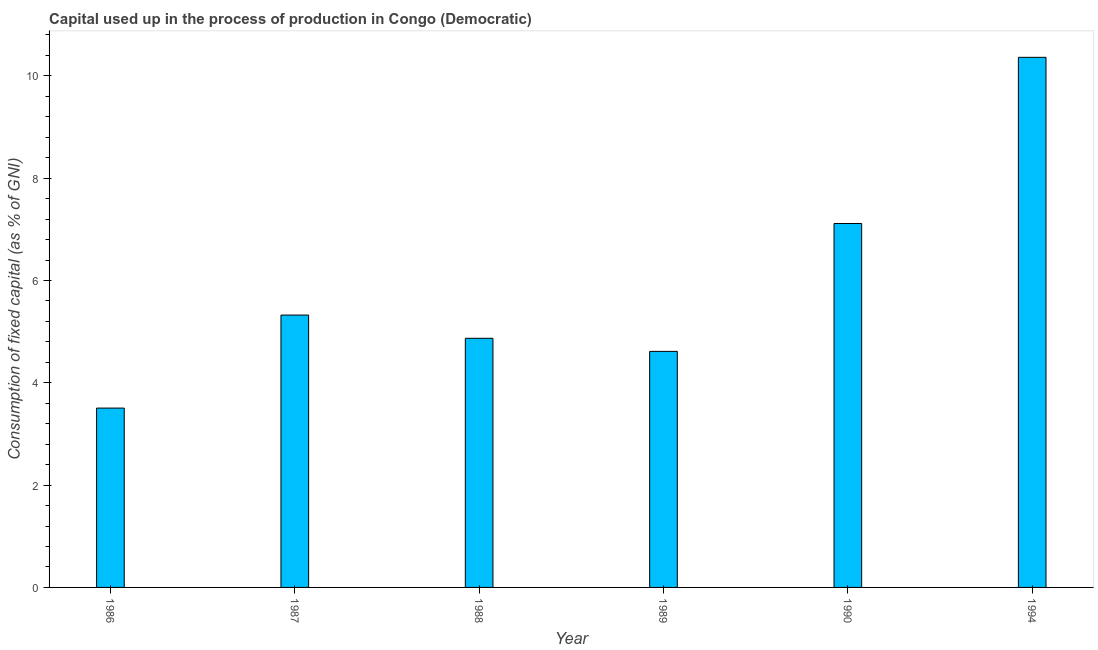What is the title of the graph?
Provide a succinct answer. Capital used up in the process of production in Congo (Democratic). What is the label or title of the X-axis?
Your answer should be compact. Year. What is the label or title of the Y-axis?
Provide a succinct answer. Consumption of fixed capital (as % of GNI). What is the consumption of fixed capital in 1987?
Ensure brevity in your answer.  5.32. Across all years, what is the maximum consumption of fixed capital?
Give a very brief answer. 10.36. Across all years, what is the minimum consumption of fixed capital?
Offer a terse response. 3.51. What is the sum of the consumption of fixed capital?
Provide a short and direct response. 35.79. What is the difference between the consumption of fixed capital in 1987 and 1988?
Offer a very short reply. 0.45. What is the average consumption of fixed capital per year?
Provide a short and direct response. 5.97. What is the median consumption of fixed capital?
Offer a very short reply. 5.1. In how many years, is the consumption of fixed capital greater than 8.4 %?
Provide a short and direct response. 1. Do a majority of the years between 1986 and 1987 (inclusive) have consumption of fixed capital greater than 2 %?
Your answer should be compact. Yes. What is the ratio of the consumption of fixed capital in 1988 to that in 1990?
Offer a very short reply. 0.69. Is the difference between the consumption of fixed capital in 1987 and 1989 greater than the difference between any two years?
Ensure brevity in your answer.  No. What is the difference between the highest and the second highest consumption of fixed capital?
Your response must be concise. 3.25. Is the sum of the consumption of fixed capital in 1987 and 1988 greater than the maximum consumption of fixed capital across all years?
Give a very brief answer. No. What is the difference between the highest and the lowest consumption of fixed capital?
Give a very brief answer. 6.86. In how many years, is the consumption of fixed capital greater than the average consumption of fixed capital taken over all years?
Give a very brief answer. 2. How many years are there in the graph?
Give a very brief answer. 6. What is the difference between two consecutive major ticks on the Y-axis?
Offer a very short reply. 2. What is the Consumption of fixed capital (as % of GNI) in 1986?
Make the answer very short. 3.51. What is the Consumption of fixed capital (as % of GNI) of 1987?
Offer a very short reply. 5.32. What is the Consumption of fixed capital (as % of GNI) in 1988?
Offer a terse response. 4.87. What is the Consumption of fixed capital (as % of GNI) in 1989?
Ensure brevity in your answer.  4.61. What is the Consumption of fixed capital (as % of GNI) of 1990?
Offer a terse response. 7.11. What is the Consumption of fixed capital (as % of GNI) in 1994?
Your answer should be compact. 10.36. What is the difference between the Consumption of fixed capital (as % of GNI) in 1986 and 1987?
Your answer should be compact. -1.82. What is the difference between the Consumption of fixed capital (as % of GNI) in 1986 and 1988?
Make the answer very short. -1.36. What is the difference between the Consumption of fixed capital (as % of GNI) in 1986 and 1989?
Provide a short and direct response. -1.11. What is the difference between the Consumption of fixed capital (as % of GNI) in 1986 and 1990?
Your answer should be very brief. -3.61. What is the difference between the Consumption of fixed capital (as % of GNI) in 1986 and 1994?
Your response must be concise. -6.86. What is the difference between the Consumption of fixed capital (as % of GNI) in 1987 and 1988?
Offer a terse response. 0.45. What is the difference between the Consumption of fixed capital (as % of GNI) in 1987 and 1989?
Provide a succinct answer. 0.71. What is the difference between the Consumption of fixed capital (as % of GNI) in 1987 and 1990?
Provide a short and direct response. -1.79. What is the difference between the Consumption of fixed capital (as % of GNI) in 1987 and 1994?
Ensure brevity in your answer.  -5.04. What is the difference between the Consumption of fixed capital (as % of GNI) in 1988 and 1989?
Keep it short and to the point. 0.26. What is the difference between the Consumption of fixed capital (as % of GNI) in 1988 and 1990?
Your answer should be compact. -2.24. What is the difference between the Consumption of fixed capital (as % of GNI) in 1988 and 1994?
Your response must be concise. -5.49. What is the difference between the Consumption of fixed capital (as % of GNI) in 1989 and 1990?
Ensure brevity in your answer.  -2.5. What is the difference between the Consumption of fixed capital (as % of GNI) in 1989 and 1994?
Offer a very short reply. -5.75. What is the difference between the Consumption of fixed capital (as % of GNI) in 1990 and 1994?
Provide a short and direct response. -3.25. What is the ratio of the Consumption of fixed capital (as % of GNI) in 1986 to that in 1987?
Keep it short and to the point. 0.66. What is the ratio of the Consumption of fixed capital (as % of GNI) in 1986 to that in 1988?
Make the answer very short. 0.72. What is the ratio of the Consumption of fixed capital (as % of GNI) in 1986 to that in 1989?
Keep it short and to the point. 0.76. What is the ratio of the Consumption of fixed capital (as % of GNI) in 1986 to that in 1990?
Your answer should be compact. 0.49. What is the ratio of the Consumption of fixed capital (as % of GNI) in 1986 to that in 1994?
Provide a succinct answer. 0.34. What is the ratio of the Consumption of fixed capital (as % of GNI) in 1987 to that in 1988?
Offer a very short reply. 1.09. What is the ratio of the Consumption of fixed capital (as % of GNI) in 1987 to that in 1989?
Make the answer very short. 1.15. What is the ratio of the Consumption of fixed capital (as % of GNI) in 1987 to that in 1990?
Ensure brevity in your answer.  0.75. What is the ratio of the Consumption of fixed capital (as % of GNI) in 1987 to that in 1994?
Give a very brief answer. 0.51. What is the ratio of the Consumption of fixed capital (as % of GNI) in 1988 to that in 1989?
Offer a very short reply. 1.05. What is the ratio of the Consumption of fixed capital (as % of GNI) in 1988 to that in 1990?
Make the answer very short. 0.69. What is the ratio of the Consumption of fixed capital (as % of GNI) in 1988 to that in 1994?
Keep it short and to the point. 0.47. What is the ratio of the Consumption of fixed capital (as % of GNI) in 1989 to that in 1990?
Offer a terse response. 0.65. What is the ratio of the Consumption of fixed capital (as % of GNI) in 1989 to that in 1994?
Ensure brevity in your answer.  0.45. What is the ratio of the Consumption of fixed capital (as % of GNI) in 1990 to that in 1994?
Ensure brevity in your answer.  0.69. 